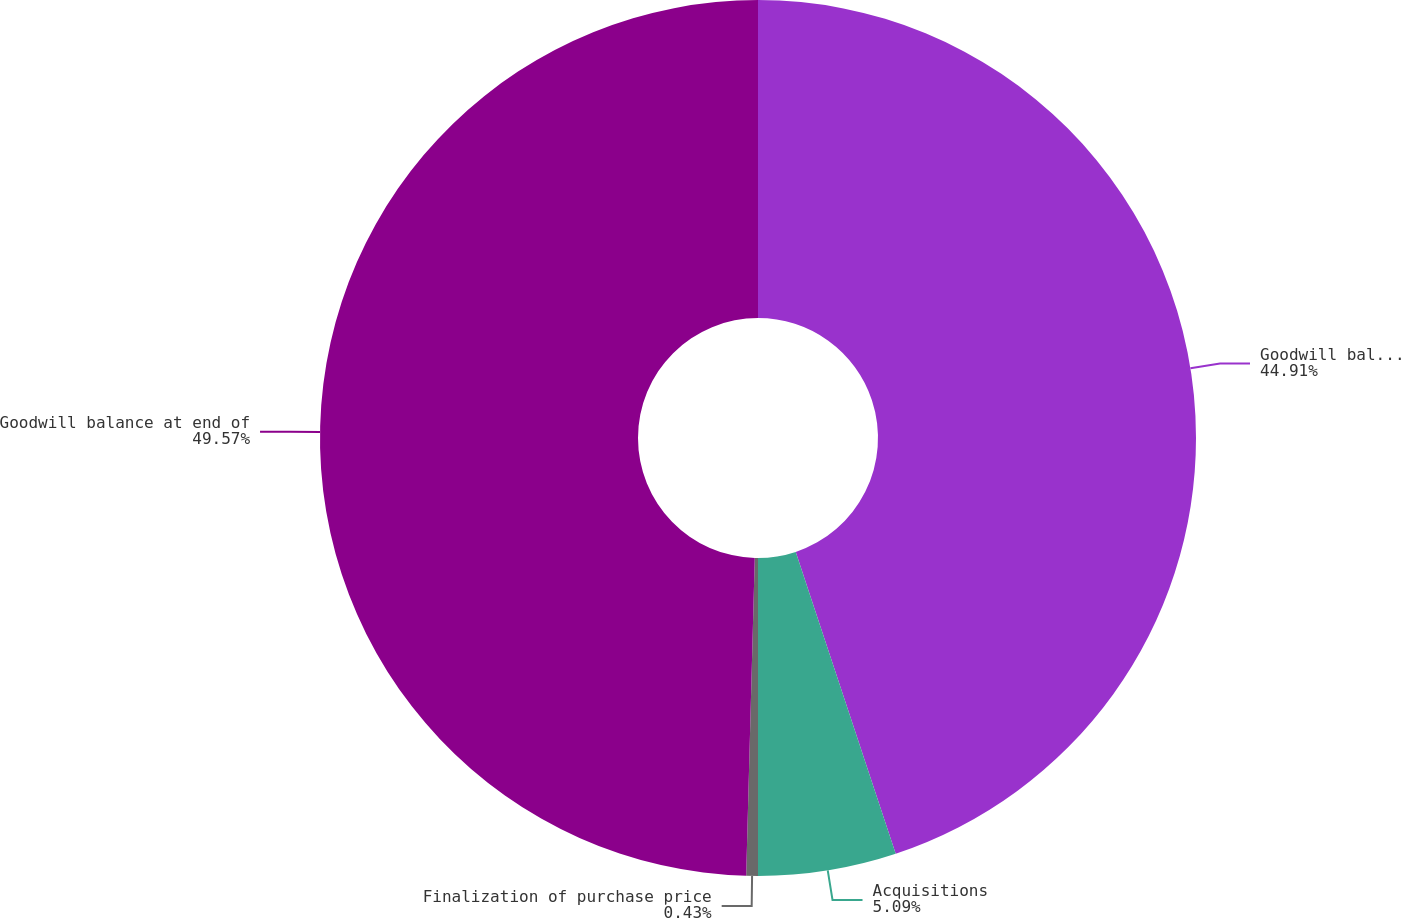<chart> <loc_0><loc_0><loc_500><loc_500><pie_chart><fcel>Goodwill balance at beginning<fcel>Acquisitions<fcel>Finalization of purchase price<fcel>Goodwill balance at end of<nl><fcel>44.91%<fcel>5.09%<fcel>0.43%<fcel>49.57%<nl></chart> 